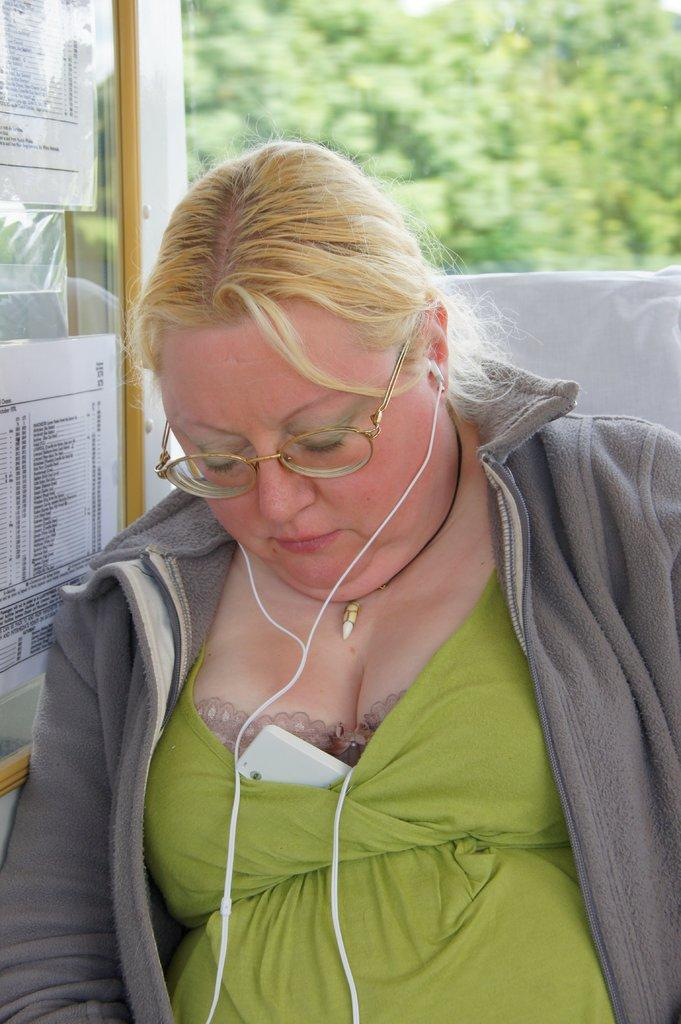Who is the main subject in the image? There is a lady in the image. What can be seen on the lady's face? The lady is wearing spectacles. What type of door is visible in the image? There is a glass door visible in the image. What is written or displayed on the glass door? There is text on the glass door. Can you tell me how many pieces of chalk are on the floor in the image? There is no chalk present in the image. What type of help is the lady providing in the image? The image does not show the lady providing any help; it only shows her wearing spectacles and standing near a glass door with text on it. 